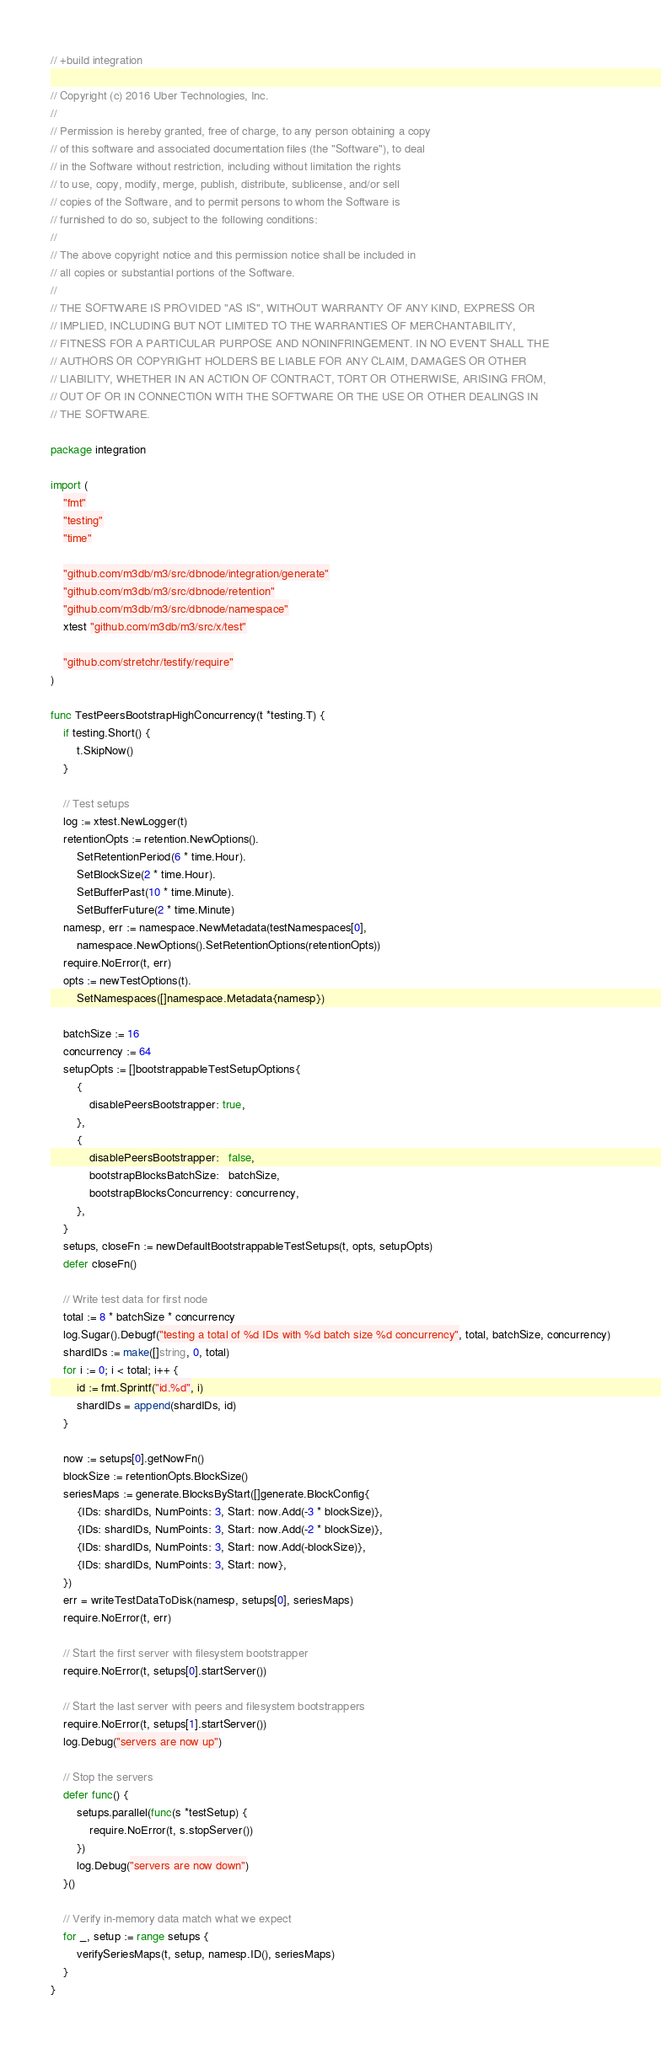Convert code to text. <code><loc_0><loc_0><loc_500><loc_500><_Go_>// +build integration

// Copyright (c) 2016 Uber Technologies, Inc.
//
// Permission is hereby granted, free of charge, to any person obtaining a copy
// of this software and associated documentation files (the "Software"), to deal
// in the Software without restriction, including without limitation the rights
// to use, copy, modify, merge, publish, distribute, sublicense, and/or sell
// copies of the Software, and to permit persons to whom the Software is
// furnished to do so, subject to the following conditions:
//
// The above copyright notice and this permission notice shall be included in
// all copies or substantial portions of the Software.
//
// THE SOFTWARE IS PROVIDED "AS IS", WITHOUT WARRANTY OF ANY KIND, EXPRESS OR
// IMPLIED, INCLUDING BUT NOT LIMITED TO THE WARRANTIES OF MERCHANTABILITY,
// FITNESS FOR A PARTICULAR PURPOSE AND NONINFRINGEMENT. IN NO EVENT SHALL THE
// AUTHORS OR COPYRIGHT HOLDERS BE LIABLE FOR ANY CLAIM, DAMAGES OR OTHER
// LIABILITY, WHETHER IN AN ACTION OF CONTRACT, TORT OR OTHERWISE, ARISING FROM,
// OUT OF OR IN CONNECTION WITH THE SOFTWARE OR THE USE OR OTHER DEALINGS IN
// THE SOFTWARE.

package integration

import (
	"fmt"
	"testing"
	"time"

	"github.com/m3db/m3/src/dbnode/integration/generate"
	"github.com/m3db/m3/src/dbnode/retention"
	"github.com/m3db/m3/src/dbnode/namespace"
	xtest "github.com/m3db/m3/src/x/test"

	"github.com/stretchr/testify/require"
)

func TestPeersBootstrapHighConcurrency(t *testing.T) {
	if testing.Short() {
		t.SkipNow()
	}

	// Test setups
	log := xtest.NewLogger(t)
	retentionOpts := retention.NewOptions().
		SetRetentionPeriod(6 * time.Hour).
		SetBlockSize(2 * time.Hour).
		SetBufferPast(10 * time.Minute).
		SetBufferFuture(2 * time.Minute)
	namesp, err := namespace.NewMetadata(testNamespaces[0],
		namespace.NewOptions().SetRetentionOptions(retentionOpts))
	require.NoError(t, err)
	opts := newTestOptions(t).
		SetNamespaces([]namespace.Metadata{namesp})

	batchSize := 16
	concurrency := 64
	setupOpts := []bootstrappableTestSetupOptions{
		{
			disablePeersBootstrapper: true,
		},
		{
			disablePeersBootstrapper:   false,
			bootstrapBlocksBatchSize:   batchSize,
			bootstrapBlocksConcurrency: concurrency,
		},
	}
	setups, closeFn := newDefaultBootstrappableTestSetups(t, opts, setupOpts)
	defer closeFn()

	// Write test data for first node
	total := 8 * batchSize * concurrency
	log.Sugar().Debugf("testing a total of %d IDs with %d batch size %d concurrency", total, batchSize, concurrency)
	shardIDs := make([]string, 0, total)
	for i := 0; i < total; i++ {
		id := fmt.Sprintf("id.%d", i)
		shardIDs = append(shardIDs, id)
	}

	now := setups[0].getNowFn()
	blockSize := retentionOpts.BlockSize()
	seriesMaps := generate.BlocksByStart([]generate.BlockConfig{
		{IDs: shardIDs, NumPoints: 3, Start: now.Add(-3 * blockSize)},
		{IDs: shardIDs, NumPoints: 3, Start: now.Add(-2 * blockSize)},
		{IDs: shardIDs, NumPoints: 3, Start: now.Add(-blockSize)},
		{IDs: shardIDs, NumPoints: 3, Start: now},
	})
	err = writeTestDataToDisk(namesp, setups[0], seriesMaps)
	require.NoError(t, err)

	// Start the first server with filesystem bootstrapper
	require.NoError(t, setups[0].startServer())

	// Start the last server with peers and filesystem bootstrappers
	require.NoError(t, setups[1].startServer())
	log.Debug("servers are now up")

	// Stop the servers
	defer func() {
		setups.parallel(func(s *testSetup) {
			require.NoError(t, s.stopServer())
		})
		log.Debug("servers are now down")
	}()

	// Verify in-memory data match what we expect
	for _, setup := range setups {
		verifySeriesMaps(t, setup, namesp.ID(), seriesMaps)
	}
}
</code> 